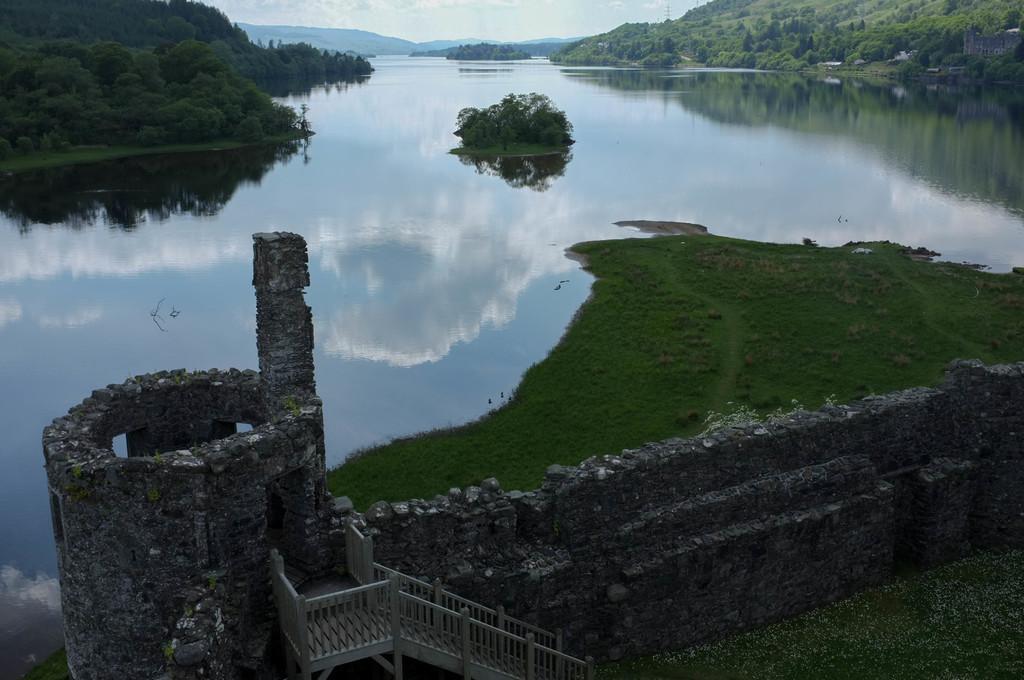Can you describe this image briefly? In this picture I can see stairs, there is water, there are plants, grass, trees, there are hills, and in the background there is sky. 